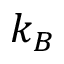Convert formula to latex. <formula><loc_0><loc_0><loc_500><loc_500>k _ { B }</formula> 